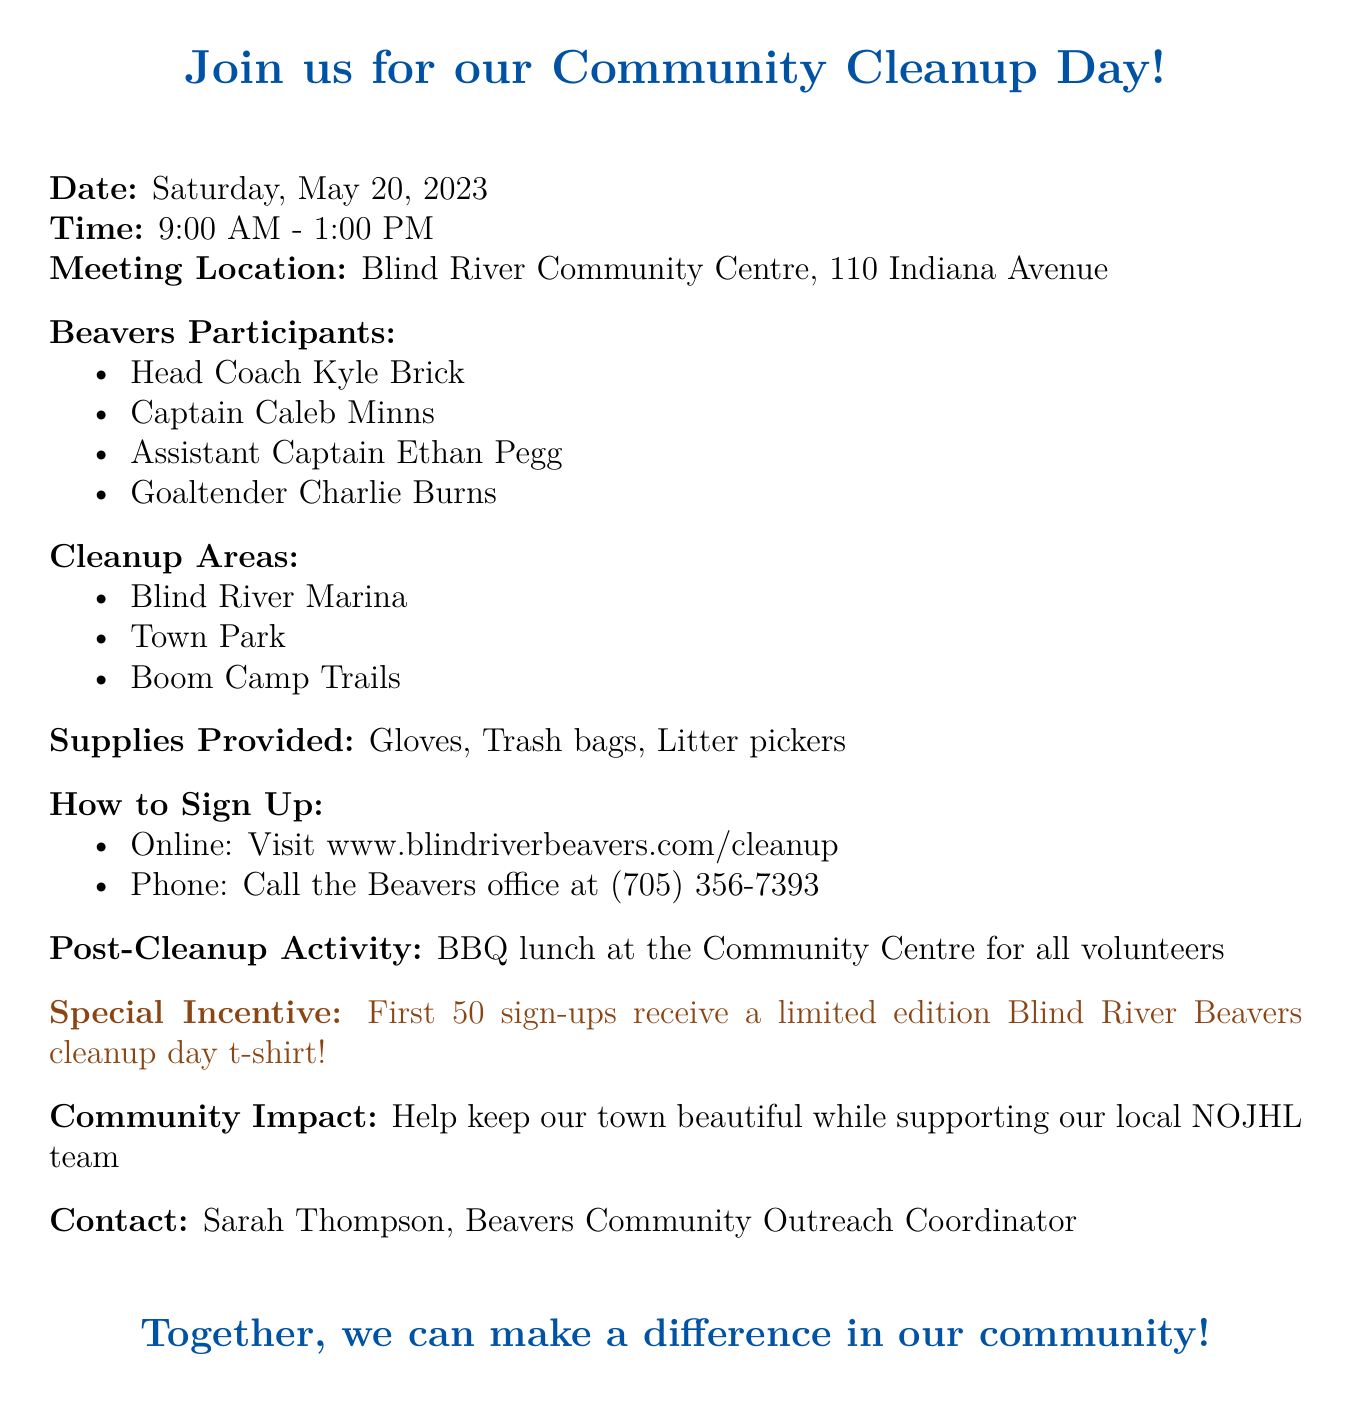What is the date of the Community Cleanup Day? The date of the event is explicitly mentioned in the document.
Answer: Saturday, May 20, 2023 What time does the Community Cleanup Day start and end? The document specifies the start and end times of the event.
Answer: 9:00 AM - 1:00 PM Where is the meeting location for volunteers? The meeting location is clearly stated in the document.
Answer: Blind River Community Centre, 110 Indiana Avenue Who are some of the Blind River Beavers participants? The document lists specific participants involved in the cleanup.
Answer: Head Coach Kyle Brick What areas will be cleaned during the event? The document provides a list of areas where cleanup activities will take place.
Answer: Blind River Marina What supplies will be provided to volunteers? The document mentions what supplies are to be provided for the cleanup event.
Answer: Gloves, Trash bags, Litter pickers How can fans sign up for the event? The document lists the methods available for signing up to participate.
Answer: Visit www.blindriverbeavers.com/cleanup What is the special incentive for signing up early? The document highlights a special offer for the first sign-ups.
Answer: Limited edition Blind River Beavers cleanup day t-shirt What will volunteers receive after the cleanup? The document mentions an activity planned for after the cleanup.
Answer: BBQ lunch at the Community Centre for all volunteers 